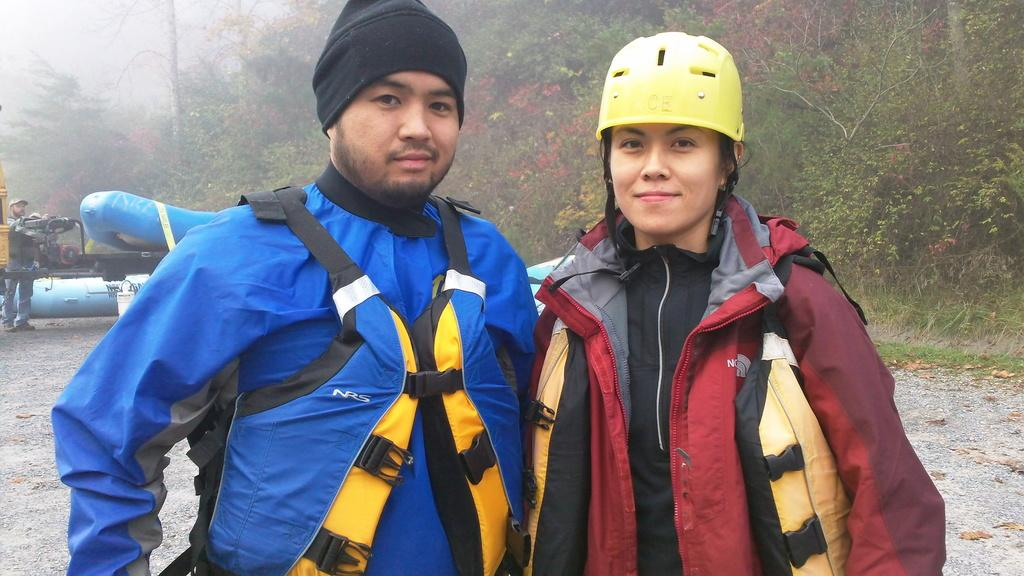What is the man in the image wearing? The man is wearing a jacket and a cap. What is the woman in the image wearing? The woman is wearing a jacket and a helmet. What can be seen in the background of the image? There are trees in the background of the image. What is the machine in the image used for? The facts do not specify the purpose of the machine, so we cannot determine its use. What type of grape is being used to set a new record in the image? There is no grape or record-setting activity present in the image. 